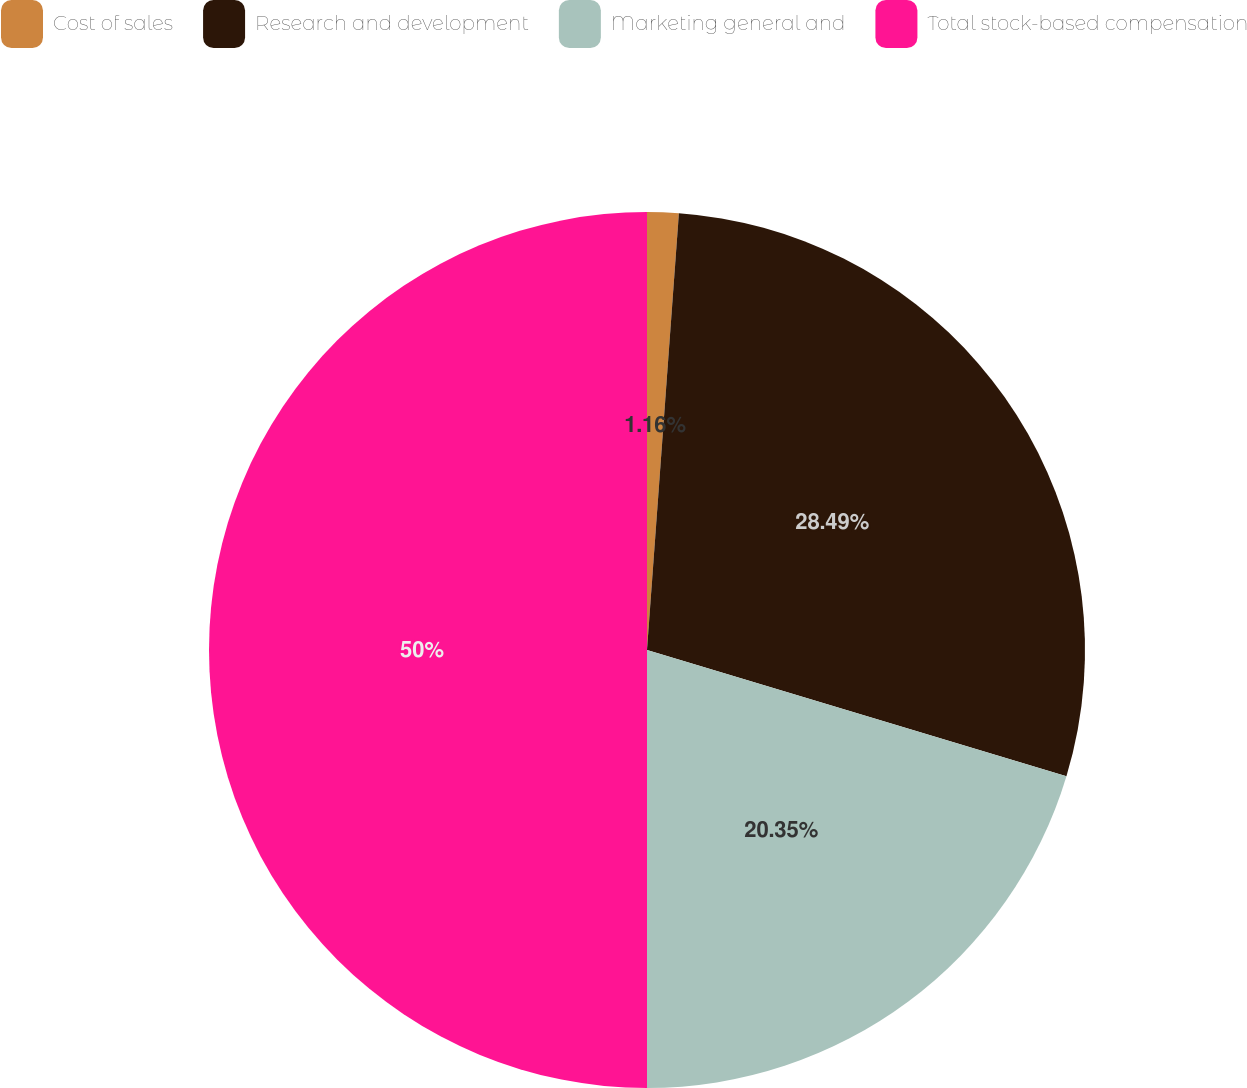Convert chart. <chart><loc_0><loc_0><loc_500><loc_500><pie_chart><fcel>Cost of sales<fcel>Research and development<fcel>Marketing general and<fcel>Total stock-based compensation<nl><fcel>1.16%<fcel>28.49%<fcel>20.35%<fcel>50.0%<nl></chart> 